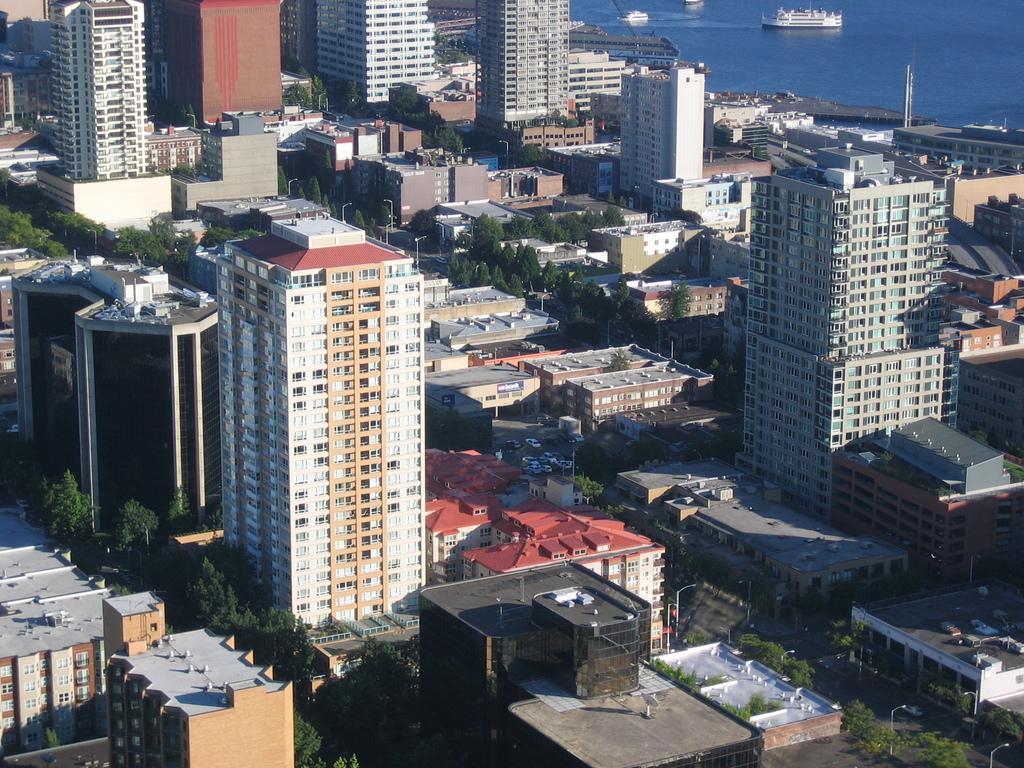In one or two sentences, can you explain what this image depicts? In this image I can see few buildings, poles, windows, trees, light poles and few vehicles on the road. I can see few ships on the water surface. 